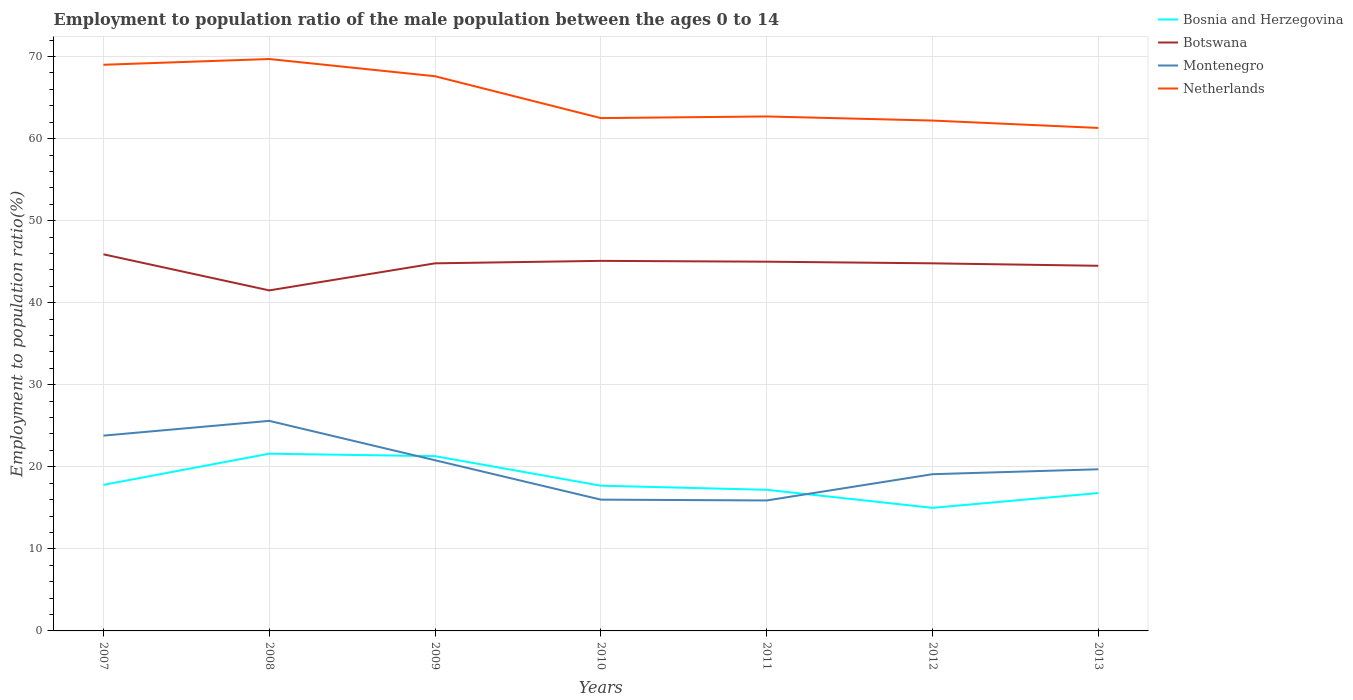Does the line corresponding to Bosnia and Herzegovina intersect with the line corresponding to Montenegro?
Your answer should be compact. Yes. Across all years, what is the maximum employment to population ratio in Netherlands?
Keep it short and to the point. 61.3. In which year was the employment to population ratio in Botswana maximum?
Offer a very short reply. 2008. What is the difference between the highest and the second highest employment to population ratio in Netherlands?
Give a very brief answer. 8.4. What is the difference between the highest and the lowest employment to population ratio in Botswana?
Your response must be concise. 5. Is the employment to population ratio in Botswana strictly greater than the employment to population ratio in Montenegro over the years?
Your answer should be very brief. No. How many lines are there?
Offer a terse response. 4. What is the difference between two consecutive major ticks on the Y-axis?
Offer a very short reply. 10. Does the graph contain any zero values?
Give a very brief answer. No. How are the legend labels stacked?
Provide a short and direct response. Vertical. What is the title of the graph?
Provide a succinct answer. Employment to population ratio of the male population between the ages 0 to 14. What is the label or title of the Y-axis?
Offer a very short reply. Employment to population ratio(%). What is the Employment to population ratio(%) in Bosnia and Herzegovina in 2007?
Provide a short and direct response. 17.8. What is the Employment to population ratio(%) in Botswana in 2007?
Provide a succinct answer. 45.9. What is the Employment to population ratio(%) in Montenegro in 2007?
Ensure brevity in your answer.  23.8. What is the Employment to population ratio(%) of Bosnia and Herzegovina in 2008?
Make the answer very short. 21.6. What is the Employment to population ratio(%) of Botswana in 2008?
Your answer should be very brief. 41.5. What is the Employment to population ratio(%) of Montenegro in 2008?
Offer a terse response. 25.6. What is the Employment to population ratio(%) of Netherlands in 2008?
Provide a short and direct response. 69.7. What is the Employment to population ratio(%) in Bosnia and Herzegovina in 2009?
Offer a very short reply. 21.3. What is the Employment to population ratio(%) of Botswana in 2009?
Make the answer very short. 44.8. What is the Employment to population ratio(%) of Montenegro in 2009?
Offer a very short reply. 20.8. What is the Employment to population ratio(%) in Netherlands in 2009?
Your answer should be very brief. 67.6. What is the Employment to population ratio(%) of Bosnia and Herzegovina in 2010?
Make the answer very short. 17.7. What is the Employment to population ratio(%) of Botswana in 2010?
Your answer should be compact. 45.1. What is the Employment to population ratio(%) of Netherlands in 2010?
Offer a very short reply. 62.5. What is the Employment to population ratio(%) in Bosnia and Herzegovina in 2011?
Provide a succinct answer. 17.2. What is the Employment to population ratio(%) of Botswana in 2011?
Offer a terse response. 45. What is the Employment to population ratio(%) of Montenegro in 2011?
Ensure brevity in your answer.  15.9. What is the Employment to population ratio(%) in Netherlands in 2011?
Your response must be concise. 62.7. What is the Employment to population ratio(%) in Botswana in 2012?
Make the answer very short. 44.8. What is the Employment to population ratio(%) in Montenegro in 2012?
Your response must be concise. 19.1. What is the Employment to population ratio(%) in Netherlands in 2012?
Provide a short and direct response. 62.2. What is the Employment to population ratio(%) in Bosnia and Herzegovina in 2013?
Your answer should be compact. 16.8. What is the Employment to population ratio(%) in Botswana in 2013?
Keep it short and to the point. 44.5. What is the Employment to population ratio(%) in Montenegro in 2013?
Keep it short and to the point. 19.7. What is the Employment to population ratio(%) of Netherlands in 2013?
Your answer should be compact. 61.3. Across all years, what is the maximum Employment to population ratio(%) of Bosnia and Herzegovina?
Keep it short and to the point. 21.6. Across all years, what is the maximum Employment to population ratio(%) of Botswana?
Keep it short and to the point. 45.9. Across all years, what is the maximum Employment to population ratio(%) of Montenegro?
Provide a succinct answer. 25.6. Across all years, what is the maximum Employment to population ratio(%) in Netherlands?
Give a very brief answer. 69.7. Across all years, what is the minimum Employment to population ratio(%) in Botswana?
Your answer should be compact. 41.5. Across all years, what is the minimum Employment to population ratio(%) of Montenegro?
Make the answer very short. 15.9. Across all years, what is the minimum Employment to population ratio(%) in Netherlands?
Keep it short and to the point. 61.3. What is the total Employment to population ratio(%) of Bosnia and Herzegovina in the graph?
Offer a very short reply. 127.4. What is the total Employment to population ratio(%) of Botswana in the graph?
Ensure brevity in your answer.  311.6. What is the total Employment to population ratio(%) in Montenegro in the graph?
Your response must be concise. 140.9. What is the total Employment to population ratio(%) in Netherlands in the graph?
Provide a short and direct response. 455. What is the difference between the Employment to population ratio(%) in Bosnia and Herzegovina in 2007 and that in 2008?
Ensure brevity in your answer.  -3.8. What is the difference between the Employment to population ratio(%) of Botswana in 2007 and that in 2009?
Your answer should be very brief. 1.1. What is the difference between the Employment to population ratio(%) of Montenegro in 2007 and that in 2009?
Your answer should be very brief. 3. What is the difference between the Employment to population ratio(%) in Netherlands in 2007 and that in 2009?
Your answer should be very brief. 1.4. What is the difference between the Employment to population ratio(%) in Botswana in 2007 and that in 2010?
Your answer should be very brief. 0.8. What is the difference between the Employment to population ratio(%) in Botswana in 2007 and that in 2011?
Your answer should be compact. 0.9. What is the difference between the Employment to population ratio(%) in Netherlands in 2007 and that in 2011?
Provide a succinct answer. 6.3. What is the difference between the Employment to population ratio(%) in Botswana in 2007 and that in 2012?
Your answer should be very brief. 1.1. What is the difference between the Employment to population ratio(%) of Montenegro in 2007 and that in 2012?
Provide a succinct answer. 4.7. What is the difference between the Employment to population ratio(%) in Netherlands in 2007 and that in 2012?
Offer a terse response. 6.8. What is the difference between the Employment to population ratio(%) in Bosnia and Herzegovina in 2007 and that in 2013?
Make the answer very short. 1. What is the difference between the Employment to population ratio(%) of Botswana in 2007 and that in 2013?
Your answer should be compact. 1.4. What is the difference between the Employment to population ratio(%) in Botswana in 2008 and that in 2009?
Provide a short and direct response. -3.3. What is the difference between the Employment to population ratio(%) in Botswana in 2008 and that in 2010?
Your answer should be very brief. -3.6. What is the difference between the Employment to population ratio(%) in Montenegro in 2008 and that in 2010?
Keep it short and to the point. 9.6. What is the difference between the Employment to population ratio(%) in Netherlands in 2008 and that in 2010?
Keep it short and to the point. 7.2. What is the difference between the Employment to population ratio(%) in Bosnia and Herzegovina in 2008 and that in 2011?
Offer a very short reply. 4.4. What is the difference between the Employment to population ratio(%) in Montenegro in 2008 and that in 2011?
Keep it short and to the point. 9.7. What is the difference between the Employment to population ratio(%) in Botswana in 2008 and that in 2012?
Keep it short and to the point. -3.3. What is the difference between the Employment to population ratio(%) of Bosnia and Herzegovina in 2008 and that in 2013?
Offer a very short reply. 4.8. What is the difference between the Employment to population ratio(%) in Montenegro in 2008 and that in 2013?
Give a very brief answer. 5.9. What is the difference between the Employment to population ratio(%) of Bosnia and Herzegovina in 2009 and that in 2010?
Offer a terse response. 3.6. What is the difference between the Employment to population ratio(%) in Bosnia and Herzegovina in 2009 and that in 2011?
Offer a terse response. 4.1. What is the difference between the Employment to population ratio(%) of Botswana in 2009 and that in 2011?
Your answer should be compact. -0.2. What is the difference between the Employment to population ratio(%) in Botswana in 2009 and that in 2012?
Your answer should be very brief. 0. What is the difference between the Employment to population ratio(%) in Bosnia and Herzegovina in 2009 and that in 2013?
Your response must be concise. 4.5. What is the difference between the Employment to population ratio(%) of Montenegro in 2009 and that in 2013?
Offer a terse response. 1.1. What is the difference between the Employment to population ratio(%) in Bosnia and Herzegovina in 2010 and that in 2011?
Your answer should be very brief. 0.5. What is the difference between the Employment to population ratio(%) of Botswana in 2010 and that in 2011?
Make the answer very short. 0.1. What is the difference between the Employment to population ratio(%) of Botswana in 2010 and that in 2012?
Offer a very short reply. 0.3. What is the difference between the Employment to population ratio(%) of Montenegro in 2010 and that in 2012?
Your response must be concise. -3.1. What is the difference between the Employment to population ratio(%) in Netherlands in 2010 and that in 2012?
Provide a short and direct response. 0.3. What is the difference between the Employment to population ratio(%) in Montenegro in 2010 and that in 2013?
Your answer should be compact. -3.7. What is the difference between the Employment to population ratio(%) of Bosnia and Herzegovina in 2011 and that in 2012?
Provide a short and direct response. 2.2. What is the difference between the Employment to population ratio(%) of Montenegro in 2011 and that in 2012?
Offer a terse response. -3.2. What is the difference between the Employment to population ratio(%) in Bosnia and Herzegovina in 2011 and that in 2013?
Keep it short and to the point. 0.4. What is the difference between the Employment to population ratio(%) in Botswana in 2011 and that in 2013?
Provide a succinct answer. 0.5. What is the difference between the Employment to population ratio(%) in Bosnia and Herzegovina in 2007 and the Employment to population ratio(%) in Botswana in 2008?
Your answer should be very brief. -23.7. What is the difference between the Employment to population ratio(%) in Bosnia and Herzegovina in 2007 and the Employment to population ratio(%) in Montenegro in 2008?
Your answer should be very brief. -7.8. What is the difference between the Employment to population ratio(%) of Bosnia and Herzegovina in 2007 and the Employment to population ratio(%) of Netherlands in 2008?
Your answer should be very brief. -51.9. What is the difference between the Employment to population ratio(%) in Botswana in 2007 and the Employment to population ratio(%) in Montenegro in 2008?
Your response must be concise. 20.3. What is the difference between the Employment to population ratio(%) in Botswana in 2007 and the Employment to population ratio(%) in Netherlands in 2008?
Provide a succinct answer. -23.8. What is the difference between the Employment to population ratio(%) in Montenegro in 2007 and the Employment to population ratio(%) in Netherlands in 2008?
Give a very brief answer. -45.9. What is the difference between the Employment to population ratio(%) in Bosnia and Herzegovina in 2007 and the Employment to population ratio(%) in Montenegro in 2009?
Make the answer very short. -3. What is the difference between the Employment to population ratio(%) in Bosnia and Herzegovina in 2007 and the Employment to population ratio(%) in Netherlands in 2009?
Make the answer very short. -49.8. What is the difference between the Employment to population ratio(%) in Botswana in 2007 and the Employment to population ratio(%) in Montenegro in 2009?
Your response must be concise. 25.1. What is the difference between the Employment to population ratio(%) of Botswana in 2007 and the Employment to population ratio(%) of Netherlands in 2009?
Offer a terse response. -21.7. What is the difference between the Employment to population ratio(%) of Montenegro in 2007 and the Employment to population ratio(%) of Netherlands in 2009?
Ensure brevity in your answer.  -43.8. What is the difference between the Employment to population ratio(%) of Bosnia and Herzegovina in 2007 and the Employment to population ratio(%) of Botswana in 2010?
Offer a very short reply. -27.3. What is the difference between the Employment to population ratio(%) of Bosnia and Herzegovina in 2007 and the Employment to population ratio(%) of Netherlands in 2010?
Your answer should be very brief. -44.7. What is the difference between the Employment to population ratio(%) of Botswana in 2007 and the Employment to population ratio(%) of Montenegro in 2010?
Offer a terse response. 29.9. What is the difference between the Employment to population ratio(%) of Botswana in 2007 and the Employment to population ratio(%) of Netherlands in 2010?
Your answer should be very brief. -16.6. What is the difference between the Employment to population ratio(%) in Montenegro in 2007 and the Employment to population ratio(%) in Netherlands in 2010?
Your response must be concise. -38.7. What is the difference between the Employment to population ratio(%) in Bosnia and Herzegovina in 2007 and the Employment to population ratio(%) in Botswana in 2011?
Provide a short and direct response. -27.2. What is the difference between the Employment to population ratio(%) in Bosnia and Herzegovina in 2007 and the Employment to population ratio(%) in Montenegro in 2011?
Your answer should be very brief. 1.9. What is the difference between the Employment to population ratio(%) in Bosnia and Herzegovina in 2007 and the Employment to population ratio(%) in Netherlands in 2011?
Your answer should be very brief. -44.9. What is the difference between the Employment to population ratio(%) in Botswana in 2007 and the Employment to population ratio(%) in Montenegro in 2011?
Give a very brief answer. 30. What is the difference between the Employment to population ratio(%) in Botswana in 2007 and the Employment to population ratio(%) in Netherlands in 2011?
Your answer should be very brief. -16.8. What is the difference between the Employment to population ratio(%) of Montenegro in 2007 and the Employment to population ratio(%) of Netherlands in 2011?
Provide a succinct answer. -38.9. What is the difference between the Employment to population ratio(%) in Bosnia and Herzegovina in 2007 and the Employment to population ratio(%) in Netherlands in 2012?
Give a very brief answer. -44.4. What is the difference between the Employment to population ratio(%) in Botswana in 2007 and the Employment to population ratio(%) in Montenegro in 2012?
Provide a succinct answer. 26.8. What is the difference between the Employment to population ratio(%) of Botswana in 2007 and the Employment to population ratio(%) of Netherlands in 2012?
Your response must be concise. -16.3. What is the difference between the Employment to population ratio(%) in Montenegro in 2007 and the Employment to population ratio(%) in Netherlands in 2012?
Keep it short and to the point. -38.4. What is the difference between the Employment to population ratio(%) in Bosnia and Herzegovina in 2007 and the Employment to population ratio(%) in Botswana in 2013?
Offer a terse response. -26.7. What is the difference between the Employment to population ratio(%) of Bosnia and Herzegovina in 2007 and the Employment to population ratio(%) of Netherlands in 2013?
Provide a succinct answer. -43.5. What is the difference between the Employment to population ratio(%) in Botswana in 2007 and the Employment to population ratio(%) in Montenegro in 2013?
Provide a succinct answer. 26.2. What is the difference between the Employment to population ratio(%) of Botswana in 2007 and the Employment to population ratio(%) of Netherlands in 2013?
Offer a terse response. -15.4. What is the difference between the Employment to population ratio(%) in Montenegro in 2007 and the Employment to population ratio(%) in Netherlands in 2013?
Your answer should be compact. -37.5. What is the difference between the Employment to population ratio(%) in Bosnia and Herzegovina in 2008 and the Employment to population ratio(%) in Botswana in 2009?
Offer a very short reply. -23.2. What is the difference between the Employment to population ratio(%) of Bosnia and Herzegovina in 2008 and the Employment to population ratio(%) of Montenegro in 2009?
Your response must be concise. 0.8. What is the difference between the Employment to population ratio(%) in Bosnia and Herzegovina in 2008 and the Employment to population ratio(%) in Netherlands in 2009?
Provide a succinct answer. -46. What is the difference between the Employment to population ratio(%) in Botswana in 2008 and the Employment to population ratio(%) in Montenegro in 2009?
Provide a succinct answer. 20.7. What is the difference between the Employment to population ratio(%) of Botswana in 2008 and the Employment to population ratio(%) of Netherlands in 2009?
Provide a short and direct response. -26.1. What is the difference between the Employment to population ratio(%) of Montenegro in 2008 and the Employment to population ratio(%) of Netherlands in 2009?
Keep it short and to the point. -42. What is the difference between the Employment to population ratio(%) of Bosnia and Herzegovina in 2008 and the Employment to population ratio(%) of Botswana in 2010?
Your answer should be very brief. -23.5. What is the difference between the Employment to population ratio(%) of Bosnia and Herzegovina in 2008 and the Employment to population ratio(%) of Montenegro in 2010?
Provide a short and direct response. 5.6. What is the difference between the Employment to population ratio(%) in Bosnia and Herzegovina in 2008 and the Employment to population ratio(%) in Netherlands in 2010?
Offer a very short reply. -40.9. What is the difference between the Employment to population ratio(%) of Montenegro in 2008 and the Employment to population ratio(%) of Netherlands in 2010?
Offer a very short reply. -36.9. What is the difference between the Employment to population ratio(%) in Bosnia and Herzegovina in 2008 and the Employment to population ratio(%) in Botswana in 2011?
Provide a short and direct response. -23.4. What is the difference between the Employment to population ratio(%) in Bosnia and Herzegovina in 2008 and the Employment to population ratio(%) in Montenegro in 2011?
Give a very brief answer. 5.7. What is the difference between the Employment to population ratio(%) in Bosnia and Herzegovina in 2008 and the Employment to population ratio(%) in Netherlands in 2011?
Offer a very short reply. -41.1. What is the difference between the Employment to population ratio(%) in Botswana in 2008 and the Employment to population ratio(%) in Montenegro in 2011?
Give a very brief answer. 25.6. What is the difference between the Employment to population ratio(%) in Botswana in 2008 and the Employment to population ratio(%) in Netherlands in 2011?
Your answer should be compact. -21.2. What is the difference between the Employment to population ratio(%) in Montenegro in 2008 and the Employment to population ratio(%) in Netherlands in 2011?
Your answer should be compact. -37.1. What is the difference between the Employment to population ratio(%) of Bosnia and Herzegovina in 2008 and the Employment to population ratio(%) of Botswana in 2012?
Your answer should be compact. -23.2. What is the difference between the Employment to population ratio(%) of Bosnia and Herzegovina in 2008 and the Employment to population ratio(%) of Montenegro in 2012?
Offer a terse response. 2.5. What is the difference between the Employment to population ratio(%) in Bosnia and Herzegovina in 2008 and the Employment to population ratio(%) in Netherlands in 2012?
Keep it short and to the point. -40.6. What is the difference between the Employment to population ratio(%) in Botswana in 2008 and the Employment to population ratio(%) in Montenegro in 2012?
Provide a short and direct response. 22.4. What is the difference between the Employment to population ratio(%) in Botswana in 2008 and the Employment to population ratio(%) in Netherlands in 2012?
Make the answer very short. -20.7. What is the difference between the Employment to population ratio(%) in Montenegro in 2008 and the Employment to population ratio(%) in Netherlands in 2012?
Give a very brief answer. -36.6. What is the difference between the Employment to population ratio(%) in Bosnia and Herzegovina in 2008 and the Employment to population ratio(%) in Botswana in 2013?
Keep it short and to the point. -22.9. What is the difference between the Employment to population ratio(%) in Bosnia and Herzegovina in 2008 and the Employment to population ratio(%) in Montenegro in 2013?
Keep it short and to the point. 1.9. What is the difference between the Employment to population ratio(%) of Bosnia and Herzegovina in 2008 and the Employment to population ratio(%) of Netherlands in 2013?
Keep it short and to the point. -39.7. What is the difference between the Employment to population ratio(%) in Botswana in 2008 and the Employment to population ratio(%) in Montenegro in 2013?
Your response must be concise. 21.8. What is the difference between the Employment to population ratio(%) of Botswana in 2008 and the Employment to population ratio(%) of Netherlands in 2013?
Your answer should be very brief. -19.8. What is the difference between the Employment to population ratio(%) of Montenegro in 2008 and the Employment to population ratio(%) of Netherlands in 2013?
Ensure brevity in your answer.  -35.7. What is the difference between the Employment to population ratio(%) of Bosnia and Herzegovina in 2009 and the Employment to population ratio(%) of Botswana in 2010?
Offer a very short reply. -23.8. What is the difference between the Employment to population ratio(%) in Bosnia and Herzegovina in 2009 and the Employment to population ratio(%) in Montenegro in 2010?
Offer a terse response. 5.3. What is the difference between the Employment to population ratio(%) of Bosnia and Herzegovina in 2009 and the Employment to population ratio(%) of Netherlands in 2010?
Provide a succinct answer. -41.2. What is the difference between the Employment to population ratio(%) in Botswana in 2009 and the Employment to population ratio(%) in Montenegro in 2010?
Provide a succinct answer. 28.8. What is the difference between the Employment to population ratio(%) of Botswana in 2009 and the Employment to population ratio(%) of Netherlands in 2010?
Keep it short and to the point. -17.7. What is the difference between the Employment to population ratio(%) in Montenegro in 2009 and the Employment to population ratio(%) in Netherlands in 2010?
Make the answer very short. -41.7. What is the difference between the Employment to population ratio(%) in Bosnia and Herzegovina in 2009 and the Employment to population ratio(%) in Botswana in 2011?
Your response must be concise. -23.7. What is the difference between the Employment to population ratio(%) of Bosnia and Herzegovina in 2009 and the Employment to population ratio(%) of Netherlands in 2011?
Provide a short and direct response. -41.4. What is the difference between the Employment to population ratio(%) in Botswana in 2009 and the Employment to population ratio(%) in Montenegro in 2011?
Give a very brief answer. 28.9. What is the difference between the Employment to population ratio(%) of Botswana in 2009 and the Employment to population ratio(%) of Netherlands in 2011?
Keep it short and to the point. -17.9. What is the difference between the Employment to population ratio(%) in Montenegro in 2009 and the Employment to population ratio(%) in Netherlands in 2011?
Make the answer very short. -41.9. What is the difference between the Employment to population ratio(%) in Bosnia and Herzegovina in 2009 and the Employment to population ratio(%) in Botswana in 2012?
Your response must be concise. -23.5. What is the difference between the Employment to population ratio(%) in Bosnia and Herzegovina in 2009 and the Employment to population ratio(%) in Montenegro in 2012?
Offer a terse response. 2.2. What is the difference between the Employment to population ratio(%) of Bosnia and Herzegovina in 2009 and the Employment to population ratio(%) of Netherlands in 2012?
Keep it short and to the point. -40.9. What is the difference between the Employment to population ratio(%) of Botswana in 2009 and the Employment to population ratio(%) of Montenegro in 2012?
Make the answer very short. 25.7. What is the difference between the Employment to population ratio(%) in Botswana in 2009 and the Employment to population ratio(%) in Netherlands in 2012?
Your answer should be very brief. -17.4. What is the difference between the Employment to population ratio(%) in Montenegro in 2009 and the Employment to population ratio(%) in Netherlands in 2012?
Your answer should be very brief. -41.4. What is the difference between the Employment to population ratio(%) in Bosnia and Herzegovina in 2009 and the Employment to population ratio(%) in Botswana in 2013?
Make the answer very short. -23.2. What is the difference between the Employment to population ratio(%) in Bosnia and Herzegovina in 2009 and the Employment to population ratio(%) in Netherlands in 2013?
Offer a very short reply. -40. What is the difference between the Employment to population ratio(%) in Botswana in 2009 and the Employment to population ratio(%) in Montenegro in 2013?
Ensure brevity in your answer.  25.1. What is the difference between the Employment to population ratio(%) of Botswana in 2009 and the Employment to population ratio(%) of Netherlands in 2013?
Provide a short and direct response. -16.5. What is the difference between the Employment to population ratio(%) of Montenegro in 2009 and the Employment to population ratio(%) of Netherlands in 2013?
Your response must be concise. -40.5. What is the difference between the Employment to population ratio(%) of Bosnia and Herzegovina in 2010 and the Employment to population ratio(%) of Botswana in 2011?
Offer a very short reply. -27.3. What is the difference between the Employment to population ratio(%) of Bosnia and Herzegovina in 2010 and the Employment to population ratio(%) of Netherlands in 2011?
Provide a short and direct response. -45. What is the difference between the Employment to population ratio(%) of Botswana in 2010 and the Employment to population ratio(%) of Montenegro in 2011?
Your response must be concise. 29.2. What is the difference between the Employment to population ratio(%) in Botswana in 2010 and the Employment to population ratio(%) in Netherlands in 2011?
Your answer should be compact. -17.6. What is the difference between the Employment to population ratio(%) in Montenegro in 2010 and the Employment to population ratio(%) in Netherlands in 2011?
Your answer should be compact. -46.7. What is the difference between the Employment to population ratio(%) of Bosnia and Herzegovina in 2010 and the Employment to population ratio(%) of Botswana in 2012?
Your answer should be compact. -27.1. What is the difference between the Employment to population ratio(%) of Bosnia and Herzegovina in 2010 and the Employment to population ratio(%) of Netherlands in 2012?
Keep it short and to the point. -44.5. What is the difference between the Employment to population ratio(%) in Botswana in 2010 and the Employment to population ratio(%) in Montenegro in 2012?
Ensure brevity in your answer.  26. What is the difference between the Employment to population ratio(%) of Botswana in 2010 and the Employment to population ratio(%) of Netherlands in 2012?
Your answer should be very brief. -17.1. What is the difference between the Employment to population ratio(%) of Montenegro in 2010 and the Employment to population ratio(%) of Netherlands in 2012?
Offer a very short reply. -46.2. What is the difference between the Employment to population ratio(%) in Bosnia and Herzegovina in 2010 and the Employment to population ratio(%) in Botswana in 2013?
Give a very brief answer. -26.8. What is the difference between the Employment to population ratio(%) in Bosnia and Herzegovina in 2010 and the Employment to population ratio(%) in Montenegro in 2013?
Offer a very short reply. -2. What is the difference between the Employment to population ratio(%) of Bosnia and Herzegovina in 2010 and the Employment to population ratio(%) of Netherlands in 2013?
Give a very brief answer. -43.6. What is the difference between the Employment to population ratio(%) in Botswana in 2010 and the Employment to population ratio(%) in Montenegro in 2013?
Give a very brief answer. 25.4. What is the difference between the Employment to population ratio(%) of Botswana in 2010 and the Employment to population ratio(%) of Netherlands in 2013?
Give a very brief answer. -16.2. What is the difference between the Employment to population ratio(%) of Montenegro in 2010 and the Employment to population ratio(%) of Netherlands in 2013?
Ensure brevity in your answer.  -45.3. What is the difference between the Employment to population ratio(%) in Bosnia and Herzegovina in 2011 and the Employment to population ratio(%) in Botswana in 2012?
Offer a very short reply. -27.6. What is the difference between the Employment to population ratio(%) in Bosnia and Herzegovina in 2011 and the Employment to population ratio(%) in Montenegro in 2012?
Offer a very short reply. -1.9. What is the difference between the Employment to population ratio(%) in Bosnia and Herzegovina in 2011 and the Employment to population ratio(%) in Netherlands in 2012?
Ensure brevity in your answer.  -45. What is the difference between the Employment to population ratio(%) of Botswana in 2011 and the Employment to population ratio(%) of Montenegro in 2012?
Ensure brevity in your answer.  25.9. What is the difference between the Employment to population ratio(%) of Botswana in 2011 and the Employment to population ratio(%) of Netherlands in 2012?
Your response must be concise. -17.2. What is the difference between the Employment to population ratio(%) of Montenegro in 2011 and the Employment to population ratio(%) of Netherlands in 2012?
Your answer should be compact. -46.3. What is the difference between the Employment to population ratio(%) of Bosnia and Herzegovina in 2011 and the Employment to population ratio(%) of Botswana in 2013?
Your answer should be compact. -27.3. What is the difference between the Employment to population ratio(%) of Bosnia and Herzegovina in 2011 and the Employment to population ratio(%) of Netherlands in 2013?
Provide a short and direct response. -44.1. What is the difference between the Employment to population ratio(%) of Botswana in 2011 and the Employment to population ratio(%) of Montenegro in 2013?
Keep it short and to the point. 25.3. What is the difference between the Employment to population ratio(%) in Botswana in 2011 and the Employment to population ratio(%) in Netherlands in 2013?
Make the answer very short. -16.3. What is the difference between the Employment to population ratio(%) in Montenegro in 2011 and the Employment to population ratio(%) in Netherlands in 2013?
Make the answer very short. -45.4. What is the difference between the Employment to population ratio(%) in Bosnia and Herzegovina in 2012 and the Employment to population ratio(%) in Botswana in 2013?
Keep it short and to the point. -29.5. What is the difference between the Employment to population ratio(%) of Bosnia and Herzegovina in 2012 and the Employment to population ratio(%) of Montenegro in 2013?
Ensure brevity in your answer.  -4.7. What is the difference between the Employment to population ratio(%) in Bosnia and Herzegovina in 2012 and the Employment to population ratio(%) in Netherlands in 2013?
Ensure brevity in your answer.  -46.3. What is the difference between the Employment to population ratio(%) of Botswana in 2012 and the Employment to population ratio(%) of Montenegro in 2013?
Provide a short and direct response. 25.1. What is the difference between the Employment to population ratio(%) of Botswana in 2012 and the Employment to population ratio(%) of Netherlands in 2013?
Provide a short and direct response. -16.5. What is the difference between the Employment to population ratio(%) in Montenegro in 2012 and the Employment to population ratio(%) in Netherlands in 2013?
Give a very brief answer. -42.2. What is the average Employment to population ratio(%) of Botswana per year?
Make the answer very short. 44.51. What is the average Employment to population ratio(%) in Montenegro per year?
Your answer should be very brief. 20.13. What is the average Employment to population ratio(%) of Netherlands per year?
Give a very brief answer. 65. In the year 2007, what is the difference between the Employment to population ratio(%) of Bosnia and Herzegovina and Employment to population ratio(%) of Botswana?
Provide a succinct answer. -28.1. In the year 2007, what is the difference between the Employment to population ratio(%) in Bosnia and Herzegovina and Employment to population ratio(%) in Montenegro?
Your answer should be compact. -6. In the year 2007, what is the difference between the Employment to population ratio(%) of Bosnia and Herzegovina and Employment to population ratio(%) of Netherlands?
Your answer should be compact. -51.2. In the year 2007, what is the difference between the Employment to population ratio(%) of Botswana and Employment to population ratio(%) of Montenegro?
Your response must be concise. 22.1. In the year 2007, what is the difference between the Employment to population ratio(%) of Botswana and Employment to population ratio(%) of Netherlands?
Provide a succinct answer. -23.1. In the year 2007, what is the difference between the Employment to population ratio(%) in Montenegro and Employment to population ratio(%) in Netherlands?
Your response must be concise. -45.2. In the year 2008, what is the difference between the Employment to population ratio(%) in Bosnia and Herzegovina and Employment to population ratio(%) in Botswana?
Make the answer very short. -19.9. In the year 2008, what is the difference between the Employment to population ratio(%) of Bosnia and Herzegovina and Employment to population ratio(%) of Netherlands?
Your answer should be very brief. -48.1. In the year 2008, what is the difference between the Employment to population ratio(%) in Botswana and Employment to population ratio(%) in Montenegro?
Offer a very short reply. 15.9. In the year 2008, what is the difference between the Employment to population ratio(%) in Botswana and Employment to population ratio(%) in Netherlands?
Provide a short and direct response. -28.2. In the year 2008, what is the difference between the Employment to population ratio(%) in Montenegro and Employment to population ratio(%) in Netherlands?
Ensure brevity in your answer.  -44.1. In the year 2009, what is the difference between the Employment to population ratio(%) of Bosnia and Herzegovina and Employment to population ratio(%) of Botswana?
Make the answer very short. -23.5. In the year 2009, what is the difference between the Employment to population ratio(%) of Bosnia and Herzegovina and Employment to population ratio(%) of Netherlands?
Offer a very short reply. -46.3. In the year 2009, what is the difference between the Employment to population ratio(%) in Botswana and Employment to population ratio(%) in Montenegro?
Your answer should be compact. 24. In the year 2009, what is the difference between the Employment to population ratio(%) of Botswana and Employment to population ratio(%) of Netherlands?
Your answer should be compact. -22.8. In the year 2009, what is the difference between the Employment to population ratio(%) in Montenegro and Employment to population ratio(%) in Netherlands?
Make the answer very short. -46.8. In the year 2010, what is the difference between the Employment to population ratio(%) of Bosnia and Herzegovina and Employment to population ratio(%) of Botswana?
Give a very brief answer. -27.4. In the year 2010, what is the difference between the Employment to population ratio(%) in Bosnia and Herzegovina and Employment to population ratio(%) in Montenegro?
Ensure brevity in your answer.  1.7. In the year 2010, what is the difference between the Employment to population ratio(%) in Bosnia and Herzegovina and Employment to population ratio(%) in Netherlands?
Ensure brevity in your answer.  -44.8. In the year 2010, what is the difference between the Employment to population ratio(%) in Botswana and Employment to population ratio(%) in Montenegro?
Make the answer very short. 29.1. In the year 2010, what is the difference between the Employment to population ratio(%) in Botswana and Employment to population ratio(%) in Netherlands?
Ensure brevity in your answer.  -17.4. In the year 2010, what is the difference between the Employment to population ratio(%) in Montenegro and Employment to population ratio(%) in Netherlands?
Offer a very short reply. -46.5. In the year 2011, what is the difference between the Employment to population ratio(%) in Bosnia and Herzegovina and Employment to population ratio(%) in Botswana?
Provide a short and direct response. -27.8. In the year 2011, what is the difference between the Employment to population ratio(%) in Bosnia and Herzegovina and Employment to population ratio(%) in Montenegro?
Make the answer very short. 1.3. In the year 2011, what is the difference between the Employment to population ratio(%) in Bosnia and Herzegovina and Employment to population ratio(%) in Netherlands?
Provide a short and direct response. -45.5. In the year 2011, what is the difference between the Employment to population ratio(%) of Botswana and Employment to population ratio(%) of Montenegro?
Give a very brief answer. 29.1. In the year 2011, what is the difference between the Employment to population ratio(%) of Botswana and Employment to population ratio(%) of Netherlands?
Offer a terse response. -17.7. In the year 2011, what is the difference between the Employment to population ratio(%) of Montenegro and Employment to population ratio(%) of Netherlands?
Offer a very short reply. -46.8. In the year 2012, what is the difference between the Employment to population ratio(%) of Bosnia and Herzegovina and Employment to population ratio(%) of Botswana?
Provide a short and direct response. -29.8. In the year 2012, what is the difference between the Employment to population ratio(%) in Bosnia and Herzegovina and Employment to population ratio(%) in Netherlands?
Your answer should be compact. -47.2. In the year 2012, what is the difference between the Employment to population ratio(%) in Botswana and Employment to population ratio(%) in Montenegro?
Make the answer very short. 25.7. In the year 2012, what is the difference between the Employment to population ratio(%) of Botswana and Employment to population ratio(%) of Netherlands?
Provide a succinct answer. -17.4. In the year 2012, what is the difference between the Employment to population ratio(%) of Montenegro and Employment to population ratio(%) of Netherlands?
Offer a terse response. -43.1. In the year 2013, what is the difference between the Employment to population ratio(%) in Bosnia and Herzegovina and Employment to population ratio(%) in Botswana?
Give a very brief answer. -27.7. In the year 2013, what is the difference between the Employment to population ratio(%) in Bosnia and Herzegovina and Employment to population ratio(%) in Netherlands?
Give a very brief answer. -44.5. In the year 2013, what is the difference between the Employment to population ratio(%) of Botswana and Employment to population ratio(%) of Montenegro?
Ensure brevity in your answer.  24.8. In the year 2013, what is the difference between the Employment to population ratio(%) of Botswana and Employment to population ratio(%) of Netherlands?
Provide a succinct answer. -16.8. In the year 2013, what is the difference between the Employment to population ratio(%) of Montenegro and Employment to population ratio(%) of Netherlands?
Keep it short and to the point. -41.6. What is the ratio of the Employment to population ratio(%) of Bosnia and Herzegovina in 2007 to that in 2008?
Keep it short and to the point. 0.82. What is the ratio of the Employment to population ratio(%) in Botswana in 2007 to that in 2008?
Your response must be concise. 1.11. What is the ratio of the Employment to population ratio(%) in Montenegro in 2007 to that in 2008?
Keep it short and to the point. 0.93. What is the ratio of the Employment to population ratio(%) of Bosnia and Herzegovina in 2007 to that in 2009?
Keep it short and to the point. 0.84. What is the ratio of the Employment to population ratio(%) in Botswana in 2007 to that in 2009?
Provide a succinct answer. 1.02. What is the ratio of the Employment to population ratio(%) in Montenegro in 2007 to that in 2009?
Offer a terse response. 1.14. What is the ratio of the Employment to population ratio(%) of Netherlands in 2007 to that in 2009?
Make the answer very short. 1.02. What is the ratio of the Employment to population ratio(%) in Bosnia and Herzegovina in 2007 to that in 2010?
Offer a terse response. 1.01. What is the ratio of the Employment to population ratio(%) in Botswana in 2007 to that in 2010?
Provide a short and direct response. 1.02. What is the ratio of the Employment to population ratio(%) in Montenegro in 2007 to that in 2010?
Keep it short and to the point. 1.49. What is the ratio of the Employment to population ratio(%) in Netherlands in 2007 to that in 2010?
Provide a succinct answer. 1.1. What is the ratio of the Employment to population ratio(%) of Bosnia and Herzegovina in 2007 to that in 2011?
Your answer should be very brief. 1.03. What is the ratio of the Employment to population ratio(%) of Montenegro in 2007 to that in 2011?
Provide a short and direct response. 1.5. What is the ratio of the Employment to population ratio(%) of Netherlands in 2007 to that in 2011?
Your response must be concise. 1.1. What is the ratio of the Employment to population ratio(%) in Bosnia and Herzegovina in 2007 to that in 2012?
Ensure brevity in your answer.  1.19. What is the ratio of the Employment to population ratio(%) of Botswana in 2007 to that in 2012?
Make the answer very short. 1.02. What is the ratio of the Employment to population ratio(%) in Montenegro in 2007 to that in 2012?
Your response must be concise. 1.25. What is the ratio of the Employment to population ratio(%) in Netherlands in 2007 to that in 2012?
Your answer should be compact. 1.11. What is the ratio of the Employment to population ratio(%) of Bosnia and Herzegovina in 2007 to that in 2013?
Provide a succinct answer. 1.06. What is the ratio of the Employment to population ratio(%) of Botswana in 2007 to that in 2013?
Provide a succinct answer. 1.03. What is the ratio of the Employment to population ratio(%) in Montenegro in 2007 to that in 2013?
Your answer should be compact. 1.21. What is the ratio of the Employment to population ratio(%) in Netherlands in 2007 to that in 2013?
Give a very brief answer. 1.13. What is the ratio of the Employment to population ratio(%) in Bosnia and Herzegovina in 2008 to that in 2009?
Your answer should be very brief. 1.01. What is the ratio of the Employment to population ratio(%) of Botswana in 2008 to that in 2009?
Make the answer very short. 0.93. What is the ratio of the Employment to population ratio(%) of Montenegro in 2008 to that in 2009?
Give a very brief answer. 1.23. What is the ratio of the Employment to population ratio(%) in Netherlands in 2008 to that in 2009?
Your response must be concise. 1.03. What is the ratio of the Employment to population ratio(%) of Bosnia and Herzegovina in 2008 to that in 2010?
Give a very brief answer. 1.22. What is the ratio of the Employment to population ratio(%) in Botswana in 2008 to that in 2010?
Ensure brevity in your answer.  0.92. What is the ratio of the Employment to population ratio(%) in Montenegro in 2008 to that in 2010?
Offer a terse response. 1.6. What is the ratio of the Employment to population ratio(%) of Netherlands in 2008 to that in 2010?
Your answer should be very brief. 1.12. What is the ratio of the Employment to population ratio(%) of Bosnia and Herzegovina in 2008 to that in 2011?
Keep it short and to the point. 1.26. What is the ratio of the Employment to population ratio(%) of Botswana in 2008 to that in 2011?
Keep it short and to the point. 0.92. What is the ratio of the Employment to population ratio(%) of Montenegro in 2008 to that in 2011?
Offer a terse response. 1.61. What is the ratio of the Employment to population ratio(%) in Netherlands in 2008 to that in 2011?
Provide a succinct answer. 1.11. What is the ratio of the Employment to population ratio(%) in Bosnia and Herzegovina in 2008 to that in 2012?
Give a very brief answer. 1.44. What is the ratio of the Employment to population ratio(%) in Botswana in 2008 to that in 2012?
Keep it short and to the point. 0.93. What is the ratio of the Employment to population ratio(%) in Montenegro in 2008 to that in 2012?
Offer a very short reply. 1.34. What is the ratio of the Employment to population ratio(%) of Netherlands in 2008 to that in 2012?
Offer a terse response. 1.12. What is the ratio of the Employment to population ratio(%) in Bosnia and Herzegovina in 2008 to that in 2013?
Your answer should be very brief. 1.29. What is the ratio of the Employment to population ratio(%) in Botswana in 2008 to that in 2013?
Offer a terse response. 0.93. What is the ratio of the Employment to population ratio(%) of Montenegro in 2008 to that in 2013?
Your answer should be compact. 1.3. What is the ratio of the Employment to population ratio(%) in Netherlands in 2008 to that in 2013?
Provide a short and direct response. 1.14. What is the ratio of the Employment to population ratio(%) of Bosnia and Herzegovina in 2009 to that in 2010?
Make the answer very short. 1.2. What is the ratio of the Employment to population ratio(%) of Netherlands in 2009 to that in 2010?
Give a very brief answer. 1.08. What is the ratio of the Employment to population ratio(%) of Bosnia and Herzegovina in 2009 to that in 2011?
Make the answer very short. 1.24. What is the ratio of the Employment to population ratio(%) of Botswana in 2009 to that in 2011?
Make the answer very short. 1. What is the ratio of the Employment to population ratio(%) in Montenegro in 2009 to that in 2011?
Provide a short and direct response. 1.31. What is the ratio of the Employment to population ratio(%) of Netherlands in 2009 to that in 2011?
Give a very brief answer. 1.08. What is the ratio of the Employment to population ratio(%) of Bosnia and Herzegovina in 2009 to that in 2012?
Offer a terse response. 1.42. What is the ratio of the Employment to population ratio(%) of Botswana in 2009 to that in 2012?
Provide a succinct answer. 1. What is the ratio of the Employment to population ratio(%) in Montenegro in 2009 to that in 2012?
Give a very brief answer. 1.09. What is the ratio of the Employment to population ratio(%) of Netherlands in 2009 to that in 2012?
Provide a short and direct response. 1.09. What is the ratio of the Employment to population ratio(%) of Bosnia and Herzegovina in 2009 to that in 2013?
Keep it short and to the point. 1.27. What is the ratio of the Employment to population ratio(%) of Botswana in 2009 to that in 2013?
Provide a short and direct response. 1.01. What is the ratio of the Employment to population ratio(%) in Montenegro in 2009 to that in 2013?
Keep it short and to the point. 1.06. What is the ratio of the Employment to population ratio(%) of Netherlands in 2009 to that in 2013?
Provide a short and direct response. 1.1. What is the ratio of the Employment to population ratio(%) of Bosnia and Herzegovina in 2010 to that in 2011?
Your answer should be compact. 1.03. What is the ratio of the Employment to population ratio(%) of Bosnia and Herzegovina in 2010 to that in 2012?
Make the answer very short. 1.18. What is the ratio of the Employment to population ratio(%) in Botswana in 2010 to that in 2012?
Provide a succinct answer. 1.01. What is the ratio of the Employment to population ratio(%) in Montenegro in 2010 to that in 2012?
Ensure brevity in your answer.  0.84. What is the ratio of the Employment to population ratio(%) in Netherlands in 2010 to that in 2012?
Your answer should be compact. 1. What is the ratio of the Employment to population ratio(%) in Bosnia and Herzegovina in 2010 to that in 2013?
Make the answer very short. 1.05. What is the ratio of the Employment to population ratio(%) of Botswana in 2010 to that in 2013?
Provide a succinct answer. 1.01. What is the ratio of the Employment to population ratio(%) in Montenegro in 2010 to that in 2013?
Ensure brevity in your answer.  0.81. What is the ratio of the Employment to population ratio(%) in Netherlands in 2010 to that in 2013?
Offer a terse response. 1.02. What is the ratio of the Employment to population ratio(%) in Bosnia and Herzegovina in 2011 to that in 2012?
Your answer should be very brief. 1.15. What is the ratio of the Employment to population ratio(%) of Botswana in 2011 to that in 2012?
Keep it short and to the point. 1. What is the ratio of the Employment to population ratio(%) in Montenegro in 2011 to that in 2012?
Give a very brief answer. 0.83. What is the ratio of the Employment to population ratio(%) of Bosnia and Herzegovina in 2011 to that in 2013?
Your response must be concise. 1.02. What is the ratio of the Employment to population ratio(%) of Botswana in 2011 to that in 2013?
Ensure brevity in your answer.  1.01. What is the ratio of the Employment to population ratio(%) in Montenegro in 2011 to that in 2013?
Your response must be concise. 0.81. What is the ratio of the Employment to population ratio(%) of Netherlands in 2011 to that in 2013?
Offer a very short reply. 1.02. What is the ratio of the Employment to population ratio(%) of Bosnia and Herzegovina in 2012 to that in 2013?
Make the answer very short. 0.89. What is the ratio of the Employment to population ratio(%) of Montenegro in 2012 to that in 2013?
Offer a very short reply. 0.97. What is the ratio of the Employment to population ratio(%) in Netherlands in 2012 to that in 2013?
Provide a short and direct response. 1.01. What is the difference between the highest and the second highest Employment to population ratio(%) of Bosnia and Herzegovina?
Ensure brevity in your answer.  0.3. What is the difference between the highest and the second highest Employment to population ratio(%) of Botswana?
Make the answer very short. 0.8. What is the difference between the highest and the second highest Employment to population ratio(%) in Netherlands?
Keep it short and to the point. 0.7. What is the difference between the highest and the lowest Employment to population ratio(%) of Netherlands?
Your answer should be very brief. 8.4. 